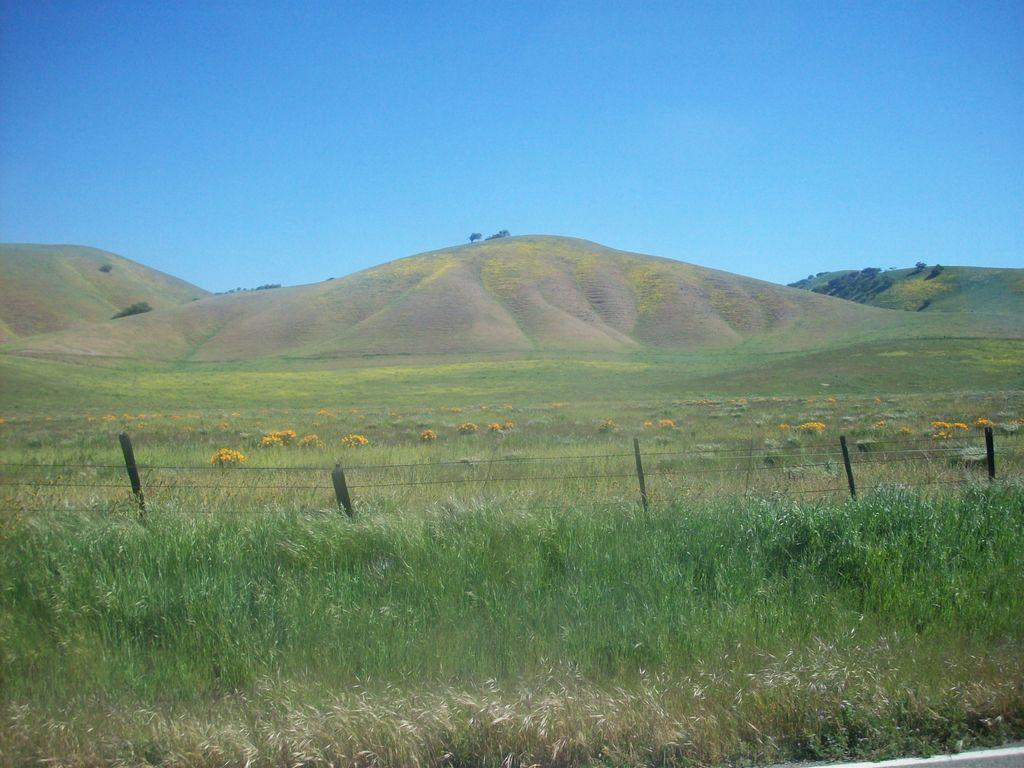What type of vegetation is on the ground in the image? There are plants on the ground in the image. What type of barrier is present in the image? There is a fence in the image. What type of flowers can be seen in the image? There are flowers in the image. What can be seen in the distance in the image? There are mountains and trees visible in the background of the image. What is visible above the plants, flowers, and fence in the image? The sky is visible in the background of the image. What type of authority is depicted in the image? There is no authority figure present in the image. What sound can be heard coming from the flowers in the image? There is no sound coming from the flowers in the image. 